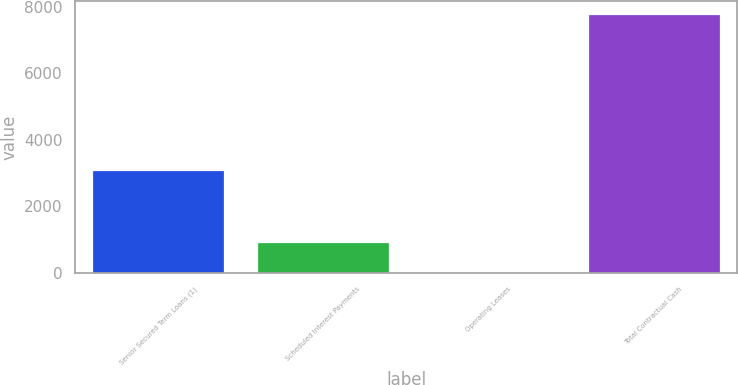Convert chart. <chart><loc_0><loc_0><loc_500><loc_500><bar_chart><fcel>Senior Secured Term Loans (1)<fcel>Scheduled Interest Payments<fcel>Operating Leases<fcel>Total Contractual Cash<nl><fcel>3093.6<fcel>909.4<fcel>30.2<fcel>7783.2<nl></chart> 